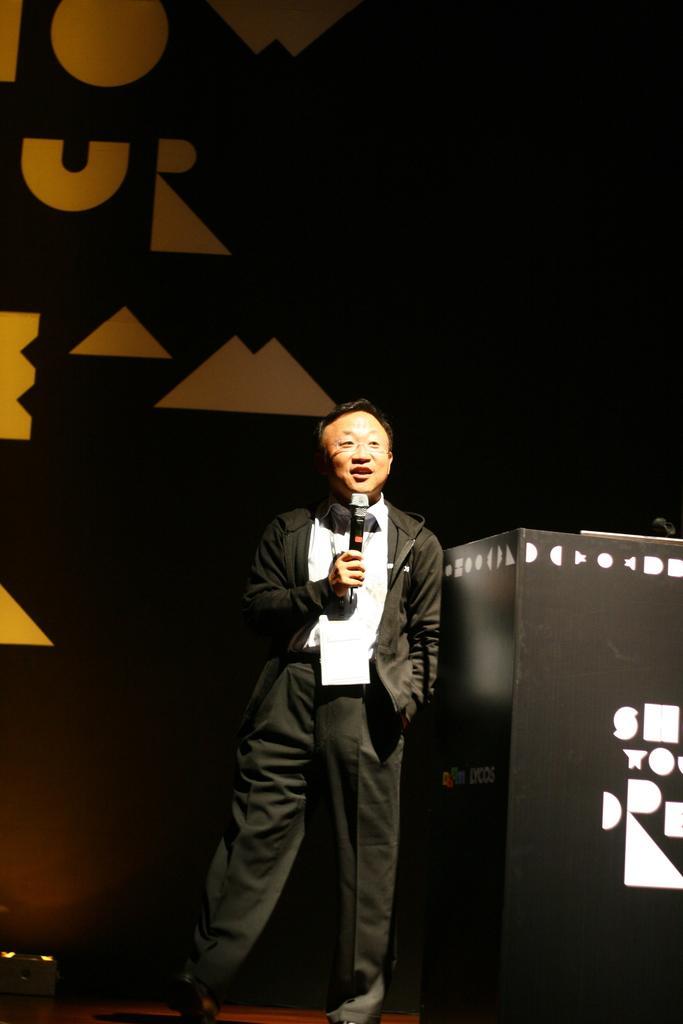In one or two sentences, can you explain what this image depicts? This is the man standing and holding the mike. He wore a suit, shirt and trouser. This looks like a podium. In the background, I can see the hoarding. 